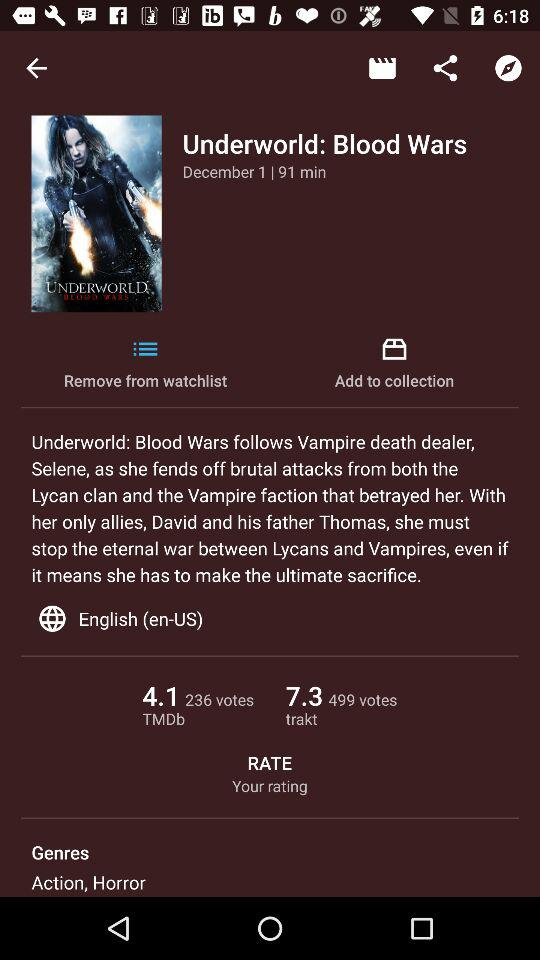What is the difference in rating between IMDB and TMDb?
Answer the question using a single word or phrase. 3.2 